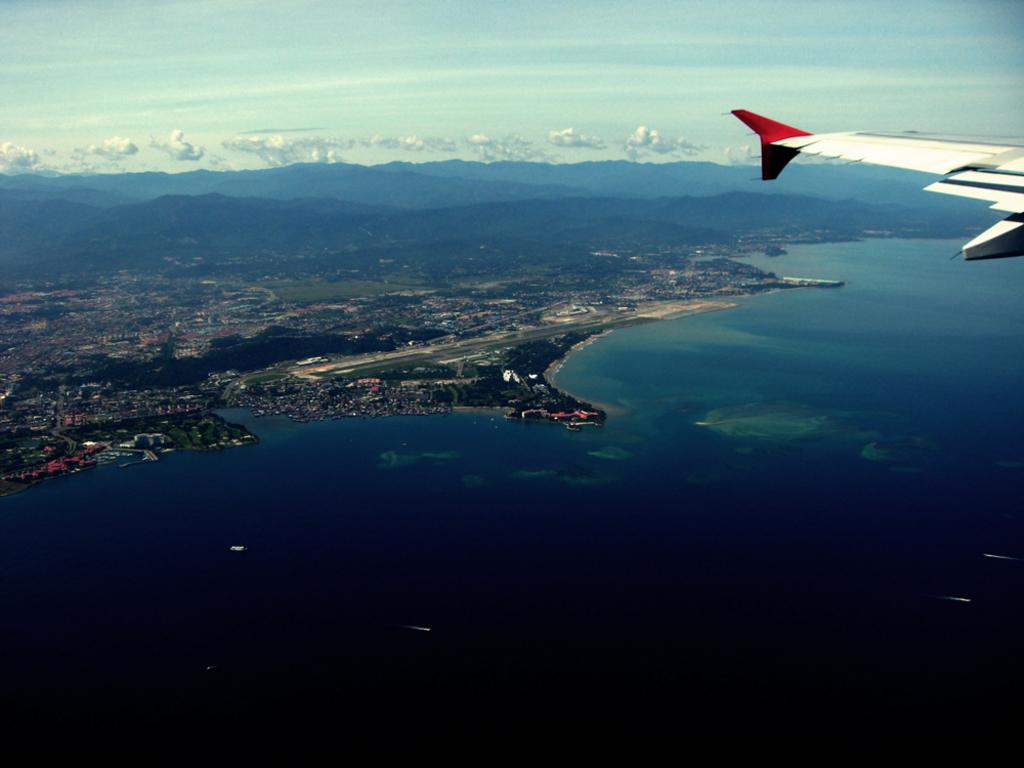What is flying in the sky in the image? There is an airplane flying in the sky in the image. What can be seen at the bottom of the image? There is a shipyard at the bottom of the image. What type of natural landform is visible in the image? There are mountains visible in the image. What is the airplane flying over in the image? There is water visible in the image, which the airplane is flying over. What type of camp can be seen near the mountains in the image? There is no camp present in the image; it only features an airplane, a shipyard, mountains, and water. 